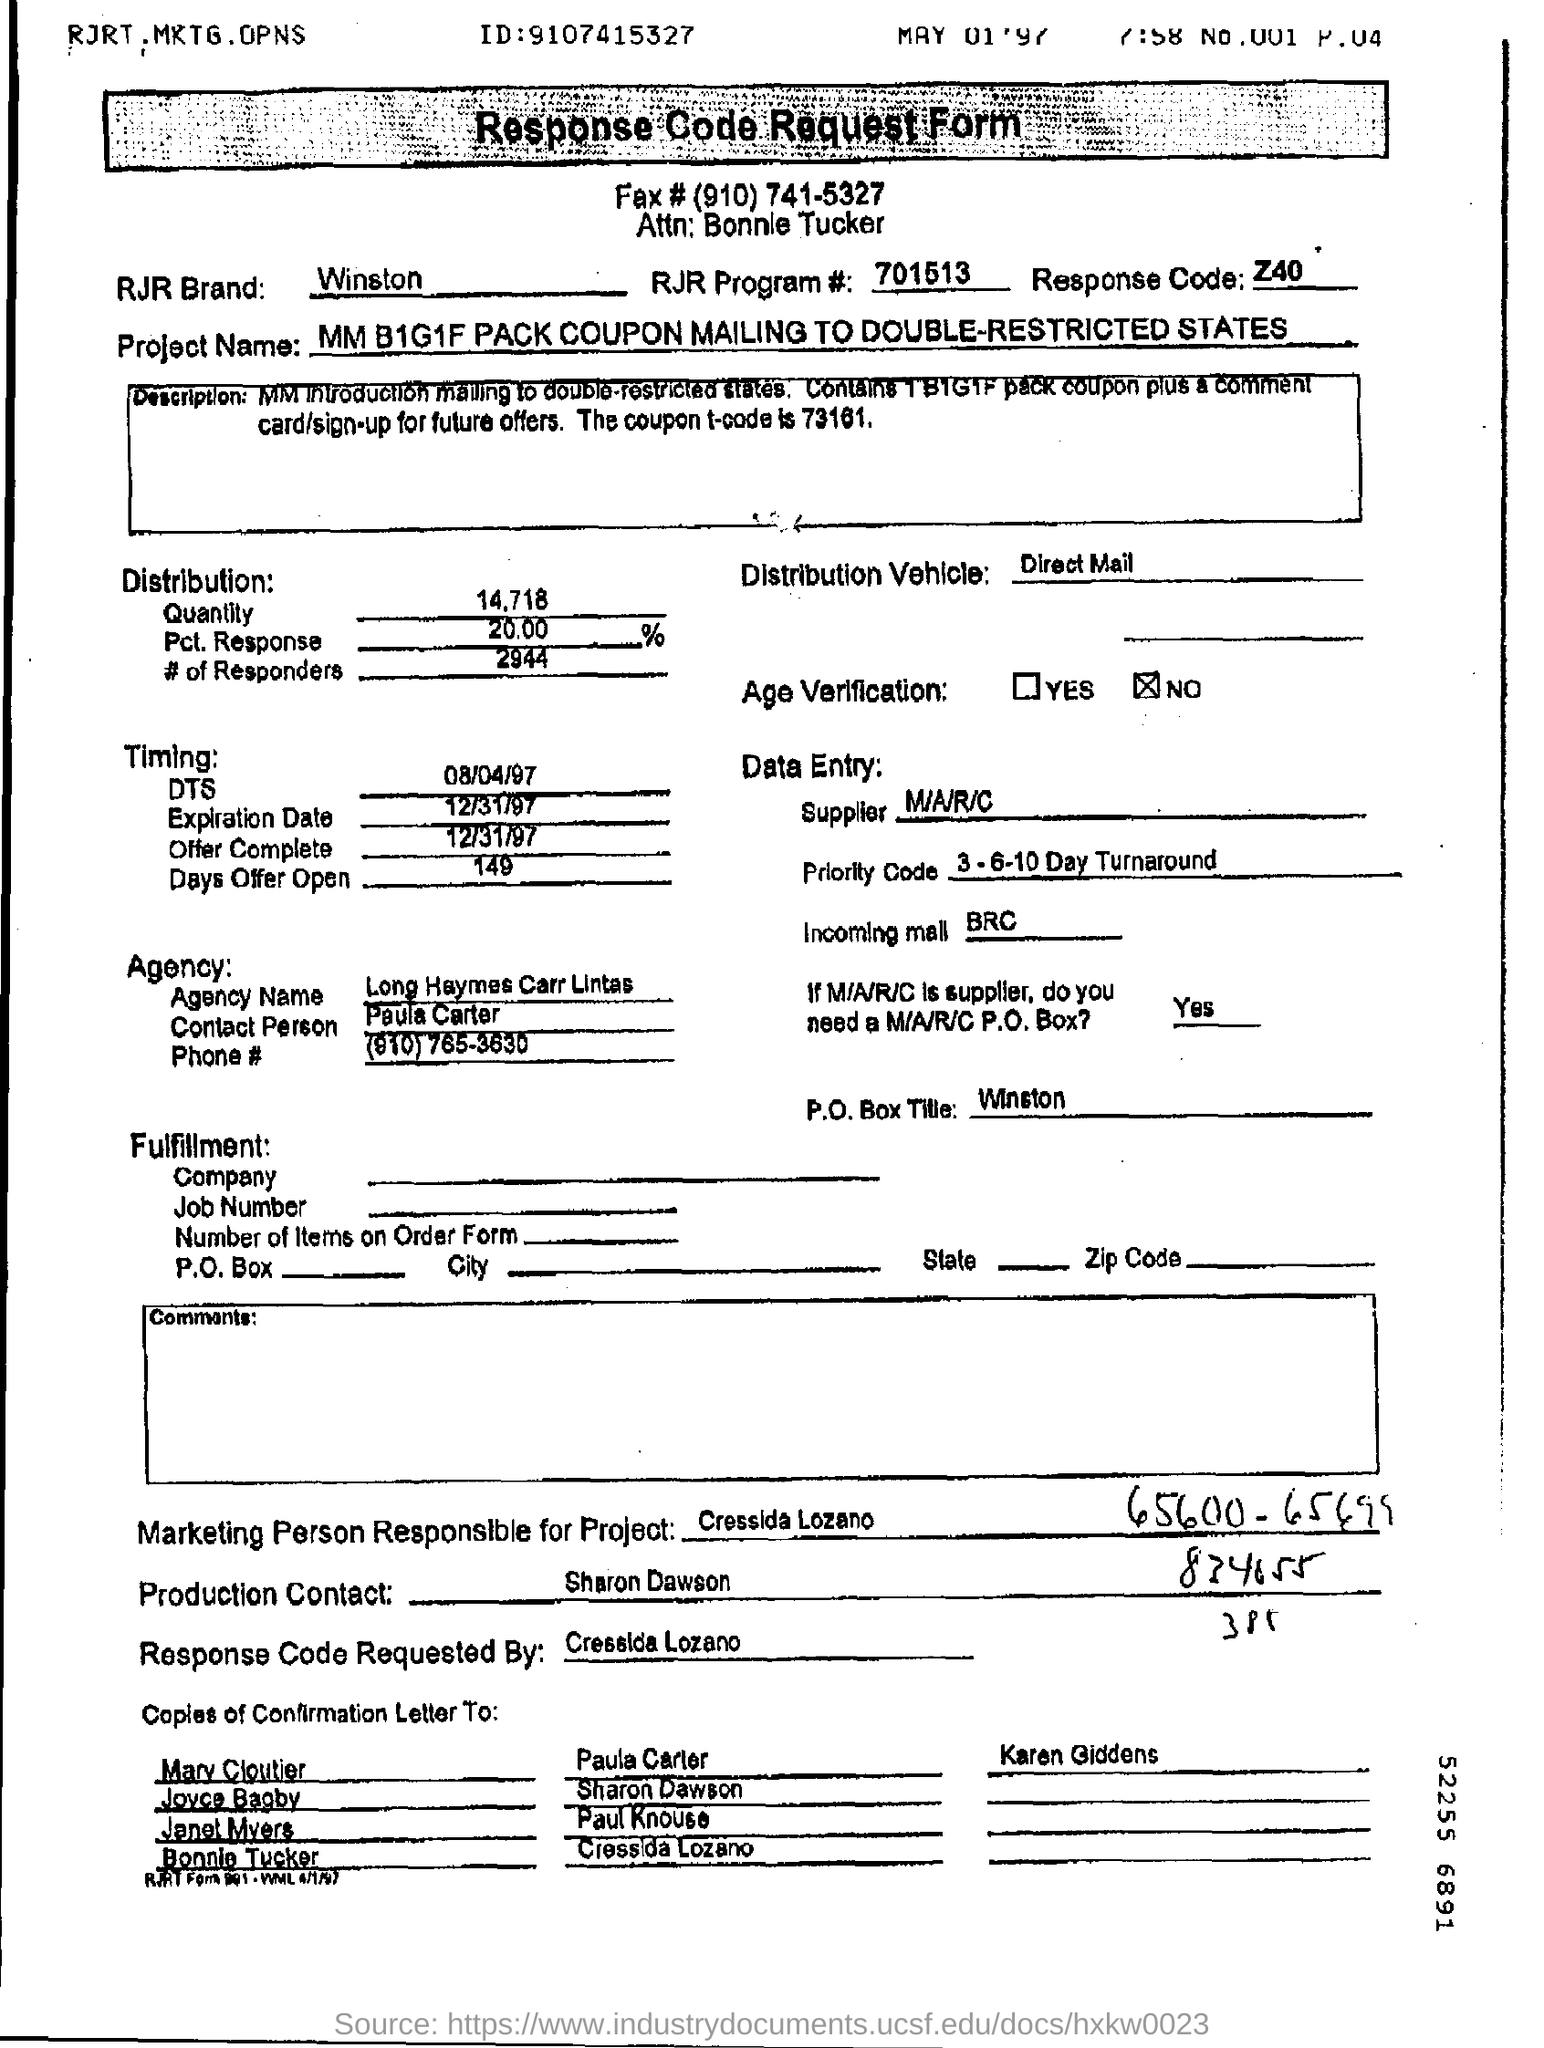What information is required from the contact person or agency on this form? The form requests the contact person's name, which is provided as Paula Contos, along with a phone number. Also, an agency is listed - Long Haymes Carr Lintas, pointing to the advertising or marketing agency handling the project. 